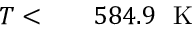<formula> <loc_0><loc_0><loc_500><loc_500>\begin{array} { r l r } { T < } & { 5 8 4 . 9 K } \end{array}</formula> 